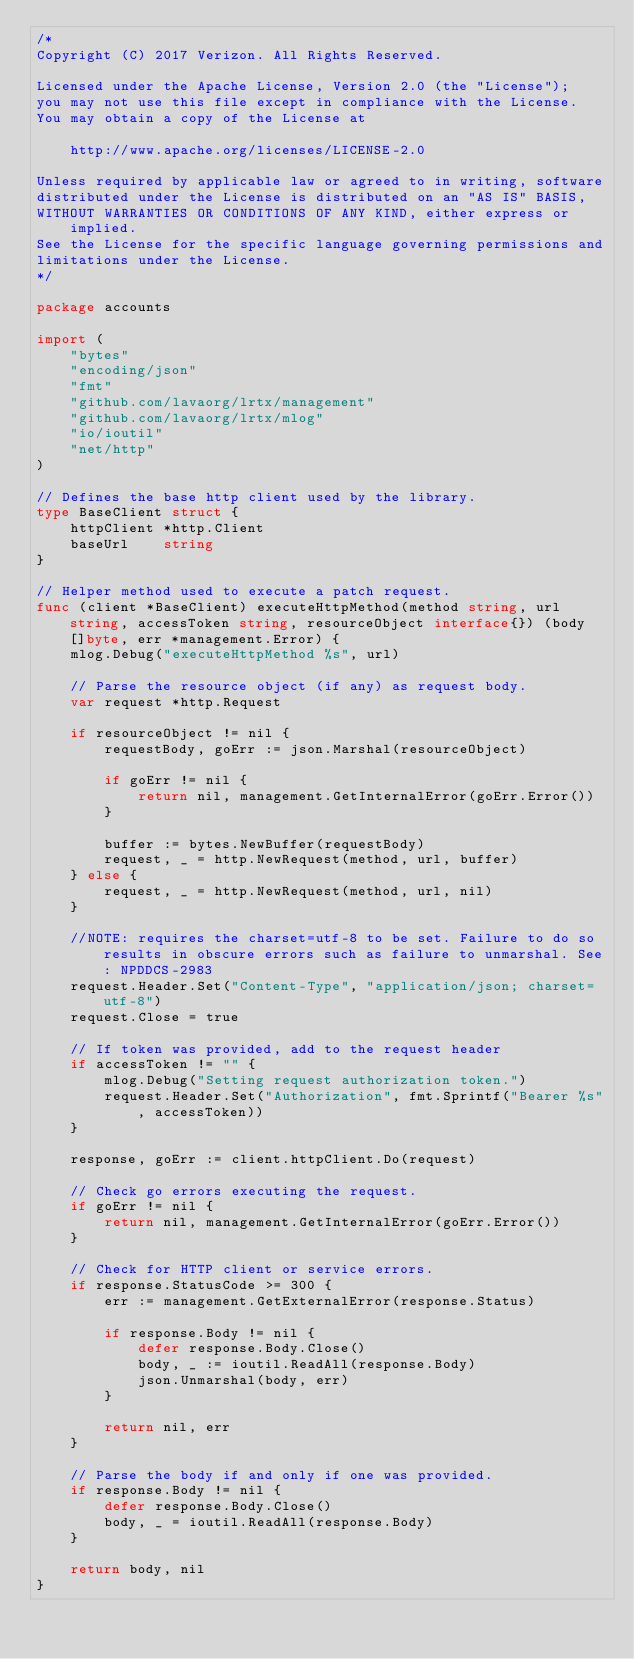Convert code to text. <code><loc_0><loc_0><loc_500><loc_500><_Go_>/*
Copyright (C) 2017 Verizon. All Rights Reserved.

Licensed under the Apache License, Version 2.0 (the "License");
you may not use this file except in compliance with the License.
You may obtain a copy of the License at

    http://www.apache.org/licenses/LICENSE-2.0

Unless required by applicable law or agreed to in writing, software
distributed under the License is distributed on an "AS IS" BASIS,
WITHOUT WARRANTIES OR CONDITIONS OF ANY KIND, either express or implied.
See the License for the specific language governing permissions and
limitations under the License.
*/

package accounts

import (
	"bytes"
	"encoding/json"
	"fmt"
	"github.com/lavaorg/lrtx/management"
	"github.com/lavaorg/lrtx/mlog"
	"io/ioutil"
	"net/http"
)

// Defines the base http client used by the library.
type BaseClient struct {
	httpClient *http.Client
	baseUrl    string
}

// Helper method used to execute a patch request.
func (client *BaseClient) executeHttpMethod(method string, url string, accessToken string, resourceObject interface{}) (body []byte, err *management.Error) {
	mlog.Debug("executeHttpMethod %s", url)

	// Parse the resource object (if any) as request body.
	var request *http.Request

	if resourceObject != nil {
		requestBody, goErr := json.Marshal(resourceObject)

		if goErr != nil {
			return nil, management.GetInternalError(goErr.Error())
		}

		buffer := bytes.NewBuffer(requestBody)
		request, _ = http.NewRequest(method, url, buffer)
	} else {
		request, _ = http.NewRequest(method, url, nil)
	}

	//NOTE: requires the charset=utf-8 to be set. Failure to do so results in obscure errors such as failure to unmarshal. See: NPDDCS-2983
	request.Header.Set("Content-Type", "application/json; charset=utf-8")
	request.Close = true

	// If token was provided, add to the request header
	if accessToken != "" {
		mlog.Debug("Setting request authorization token.")
		request.Header.Set("Authorization", fmt.Sprintf("Bearer %s", accessToken))
	}

	response, goErr := client.httpClient.Do(request)

	// Check go errors executing the request.
	if goErr != nil {
		return nil, management.GetInternalError(goErr.Error())
	}

	// Check for HTTP client or service errors.
	if response.StatusCode >= 300 {
		err := management.GetExternalError(response.Status)

		if response.Body != nil {
			defer response.Body.Close()
			body, _ := ioutil.ReadAll(response.Body)
			json.Unmarshal(body, err)
		}

		return nil, err
	}

	// Parse the body if and only if one was provided.
	if response.Body != nil {
		defer response.Body.Close()
		body, _ = ioutil.ReadAll(response.Body)
	}

	return body, nil
}
</code> 